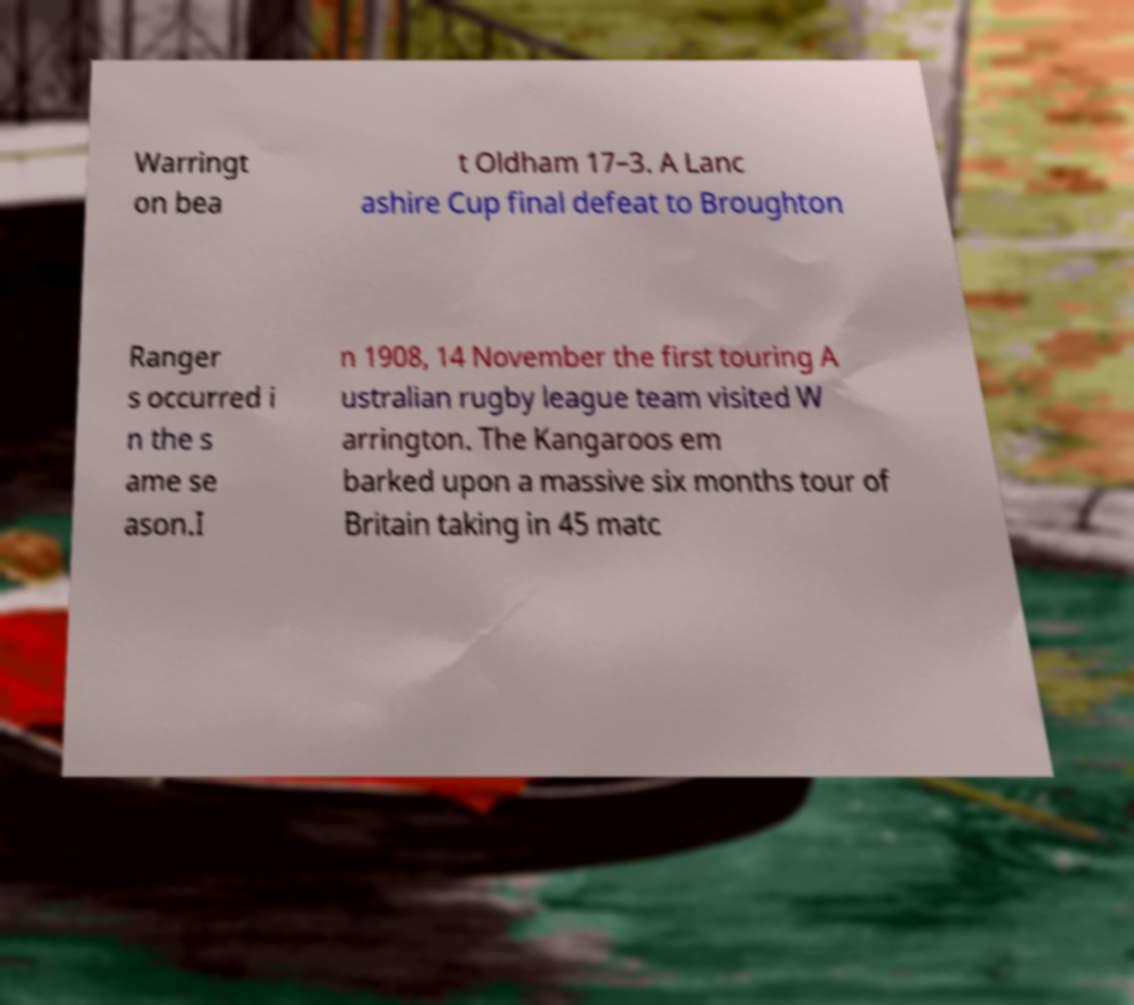Can you read and provide the text displayed in the image?This photo seems to have some interesting text. Can you extract and type it out for me? Warringt on bea t Oldham 17–3. A Lanc ashire Cup final defeat to Broughton Ranger s occurred i n the s ame se ason.I n 1908, 14 November the first touring A ustralian rugby league team visited W arrington. The Kangaroos em barked upon a massive six months tour of Britain taking in 45 matc 